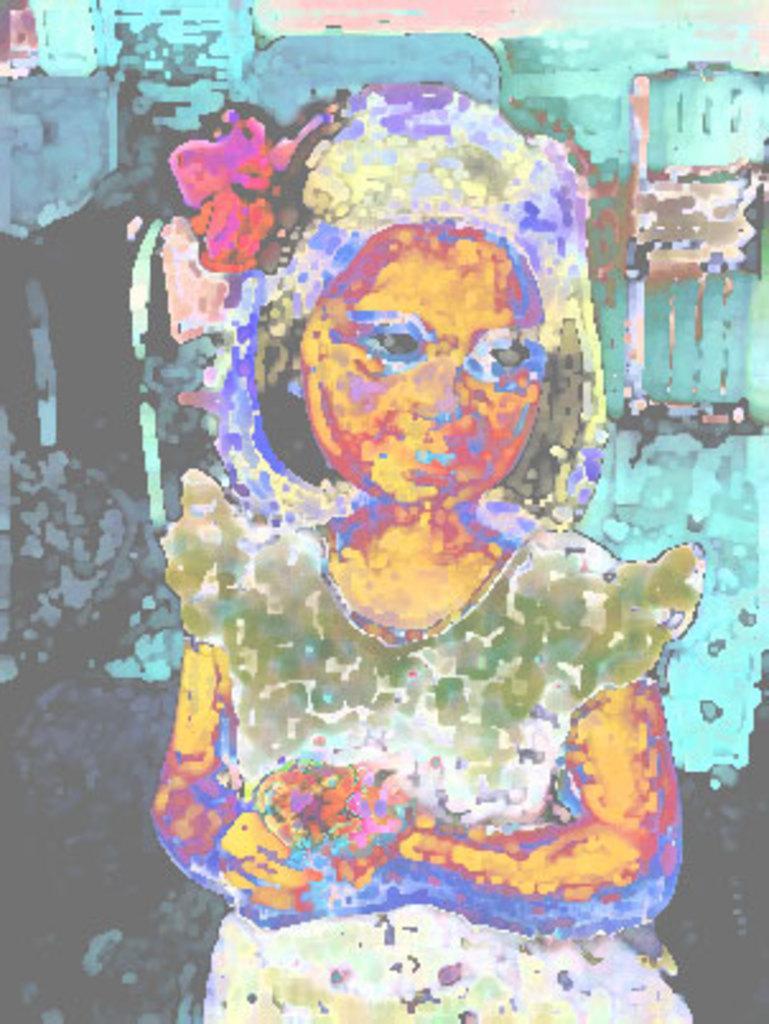Could you give a brief overview of what you see in this image? In this image I can see a photograph of a girl standing and I can see the picture is edited with some effect. 